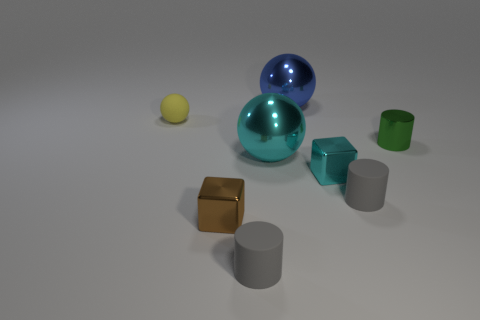Is the number of tiny brown matte blocks greater than the number of yellow matte things? no 